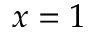<formula> <loc_0><loc_0><loc_500><loc_500>x = 1</formula> 